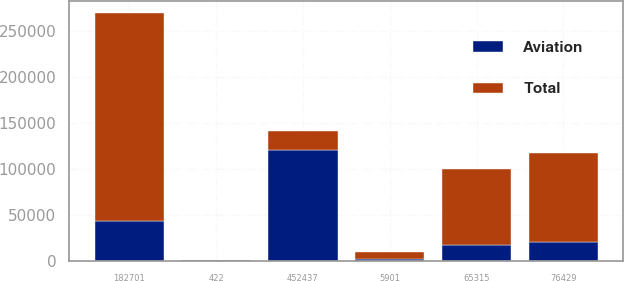Convert chart to OTSL. <chart><loc_0><loc_0><loc_500><loc_500><stacked_bar_chart><ecel><fcel>452437<fcel>5901<fcel>422<fcel>182701<fcel>65315<fcel>76429<nl><fcel>Aviation<fcel>120552<fcel>1572<fcel>112<fcel>43242<fcel>17403<fcel>20365<nl><fcel>Total<fcel>20365<fcel>7473<fcel>534<fcel>225943<fcel>82718<fcel>96794<nl></chart> 